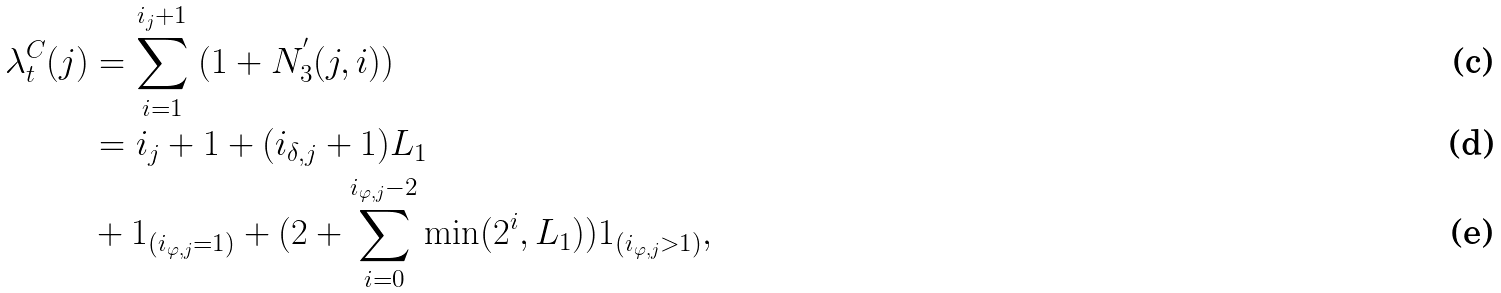<formula> <loc_0><loc_0><loc_500><loc_500>\lambda _ { t } ^ { C } ( j ) & = \sum _ { i = 1 } ^ { i _ { j } + 1 } \ ( 1 + N ^ { ^ { \prime } } _ { 3 } ( j , i ) ) \\ & = i _ { j } + 1 + ( i _ { \delta , j } + 1 ) L _ { 1 } \\ & + 1 _ { ( i _ { \varphi , j } = 1 ) } + ( 2 + \sum _ { i = 0 } ^ { i _ { \varphi , j } - 2 } \min ( 2 ^ { i } , L _ { 1 } ) ) 1 _ { ( i _ { \varphi , j } > 1 ) } ,</formula> 